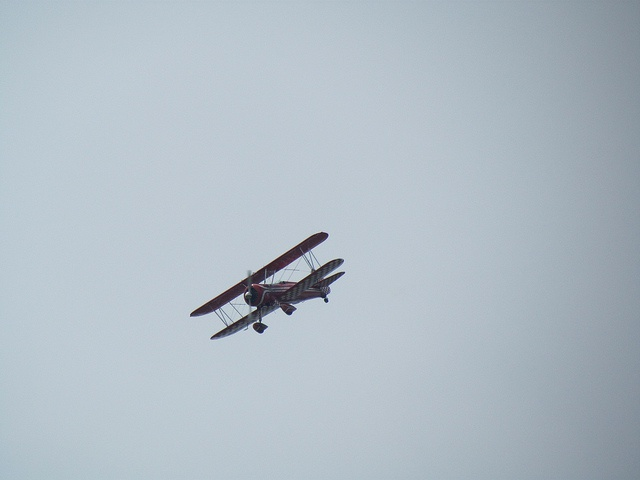Describe the objects in this image and their specific colors. I can see a airplane in darkgray, black, and gray tones in this image. 